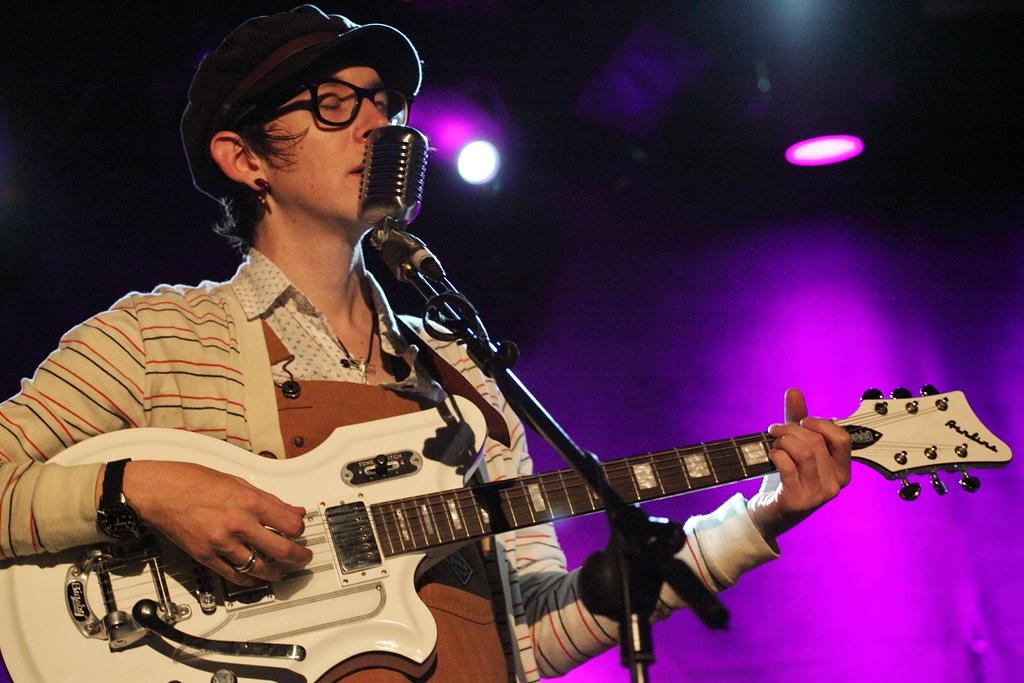What is the person in the image doing? The person is playing a guitar. What accessories is the person wearing? The person is wearing spectacles and a cap. What is the person standing in front of? The person is standing before a microphone stand. What can be seen in the background of the image? There are lights in the background of the image. What type of suit is the person wearing in the image? There is no suit visible in the image; the person is wearing spectacles and a cap. What discovery was made by the person in the image? There is no indication of a discovery being made in the image; the person is playing a guitar. 